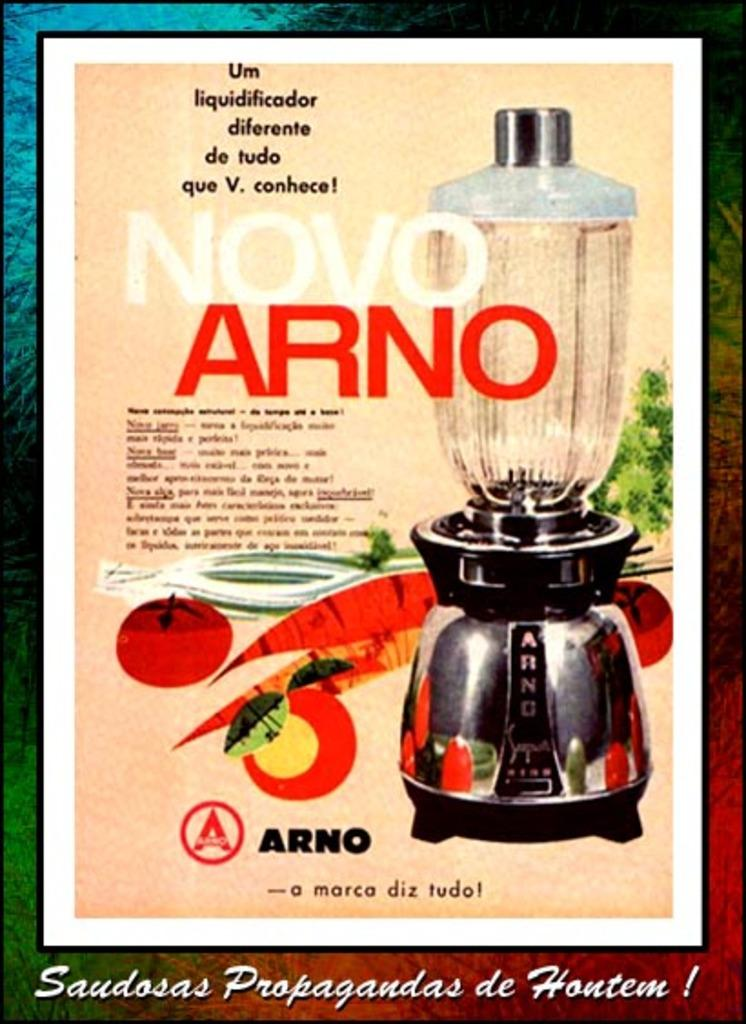<image>
Relay a brief, clear account of the picture shown. Novo Arno Blender shown with different vegetables on screen. 